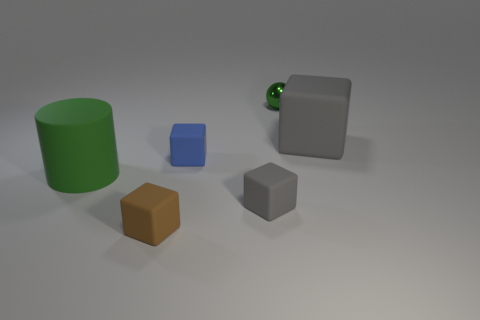Subtract all brown balls. How many gray blocks are left? 2 Add 1 tiny brown cubes. How many objects exist? 7 Subtract all small cubes. How many cubes are left? 1 Subtract all brown blocks. How many blocks are left? 3 Subtract all green cubes. Subtract all blue balls. How many cubes are left? 4 Subtract all cylinders. How many objects are left? 5 Add 1 tiny yellow metal things. How many tiny yellow metal things exist? 1 Subtract 0 gray balls. How many objects are left? 6 Subtract all tiny gray cubes. Subtract all matte blocks. How many objects are left? 1 Add 5 large matte cubes. How many large matte cubes are left? 6 